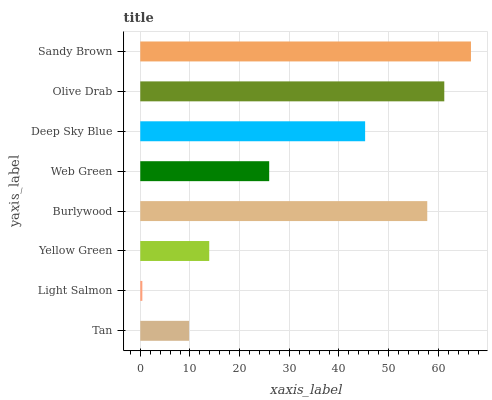Is Light Salmon the minimum?
Answer yes or no. Yes. Is Sandy Brown the maximum?
Answer yes or no. Yes. Is Yellow Green the minimum?
Answer yes or no. No. Is Yellow Green the maximum?
Answer yes or no. No. Is Yellow Green greater than Light Salmon?
Answer yes or no. Yes. Is Light Salmon less than Yellow Green?
Answer yes or no. Yes. Is Light Salmon greater than Yellow Green?
Answer yes or no. No. Is Yellow Green less than Light Salmon?
Answer yes or no. No. Is Deep Sky Blue the high median?
Answer yes or no. Yes. Is Web Green the low median?
Answer yes or no. Yes. Is Tan the high median?
Answer yes or no. No. Is Deep Sky Blue the low median?
Answer yes or no. No. 